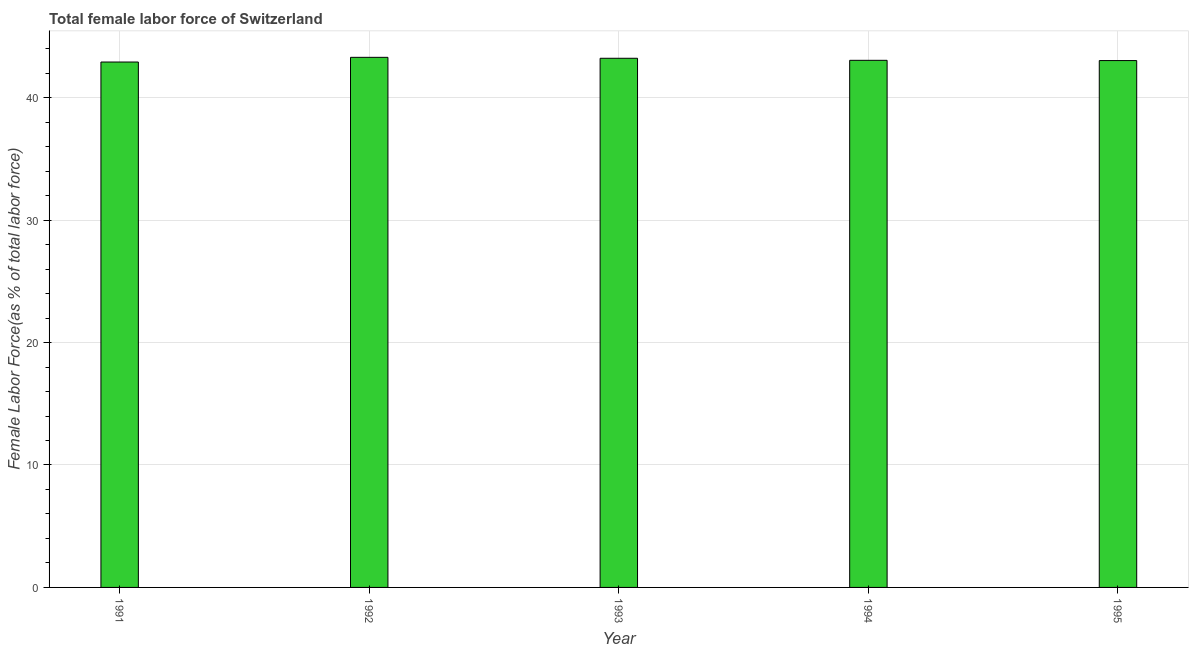What is the title of the graph?
Your response must be concise. Total female labor force of Switzerland. What is the label or title of the X-axis?
Make the answer very short. Year. What is the label or title of the Y-axis?
Your response must be concise. Female Labor Force(as % of total labor force). What is the total female labor force in 1992?
Provide a short and direct response. 43.3. Across all years, what is the maximum total female labor force?
Keep it short and to the point. 43.3. Across all years, what is the minimum total female labor force?
Your answer should be very brief. 42.91. What is the sum of the total female labor force?
Give a very brief answer. 215.51. What is the difference between the total female labor force in 1991 and 1995?
Offer a very short reply. -0.12. What is the average total female labor force per year?
Give a very brief answer. 43.1. What is the median total female labor force?
Keep it short and to the point. 43.05. In how many years, is the total female labor force greater than 2 %?
Offer a terse response. 5. What is the ratio of the total female labor force in 1992 to that in 1993?
Provide a succinct answer. 1. Is the difference between the total female labor force in 1991 and 1994 greater than the difference between any two years?
Offer a terse response. No. What is the difference between the highest and the second highest total female labor force?
Give a very brief answer. 0.08. What is the difference between the highest and the lowest total female labor force?
Provide a succinct answer. 0.38. What is the difference between two consecutive major ticks on the Y-axis?
Provide a succinct answer. 10. What is the Female Labor Force(as % of total labor force) of 1991?
Provide a short and direct response. 42.91. What is the Female Labor Force(as % of total labor force) of 1992?
Provide a succinct answer. 43.3. What is the Female Labor Force(as % of total labor force) of 1993?
Give a very brief answer. 43.22. What is the Female Labor Force(as % of total labor force) in 1994?
Keep it short and to the point. 43.05. What is the Female Labor Force(as % of total labor force) of 1995?
Make the answer very short. 43.03. What is the difference between the Female Labor Force(as % of total labor force) in 1991 and 1992?
Keep it short and to the point. -0.38. What is the difference between the Female Labor Force(as % of total labor force) in 1991 and 1993?
Offer a very short reply. -0.31. What is the difference between the Female Labor Force(as % of total labor force) in 1991 and 1994?
Provide a succinct answer. -0.14. What is the difference between the Female Labor Force(as % of total labor force) in 1991 and 1995?
Offer a terse response. -0.12. What is the difference between the Female Labor Force(as % of total labor force) in 1992 and 1993?
Your answer should be very brief. 0.08. What is the difference between the Female Labor Force(as % of total labor force) in 1992 and 1994?
Your answer should be very brief. 0.24. What is the difference between the Female Labor Force(as % of total labor force) in 1992 and 1995?
Make the answer very short. 0.26. What is the difference between the Female Labor Force(as % of total labor force) in 1993 and 1994?
Provide a succinct answer. 0.17. What is the difference between the Female Labor Force(as % of total labor force) in 1993 and 1995?
Provide a succinct answer. 0.19. What is the difference between the Female Labor Force(as % of total labor force) in 1994 and 1995?
Offer a very short reply. 0.02. What is the ratio of the Female Labor Force(as % of total labor force) in 1991 to that in 1993?
Ensure brevity in your answer.  0.99. What is the ratio of the Female Labor Force(as % of total labor force) in 1991 to that in 1994?
Your answer should be compact. 1. What is the ratio of the Female Labor Force(as % of total labor force) in 1992 to that in 1995?
Make the answer very short. 1.01. What is the ratio of the Female Labor Force(as % of total labor force) in 1993 to that in 1994?
Your answer should be very brief. 1. What is the ratio of the Female Labor Force(as % of total labor force) in 1994 to that in 1995?
Your response must be concise. 1. 